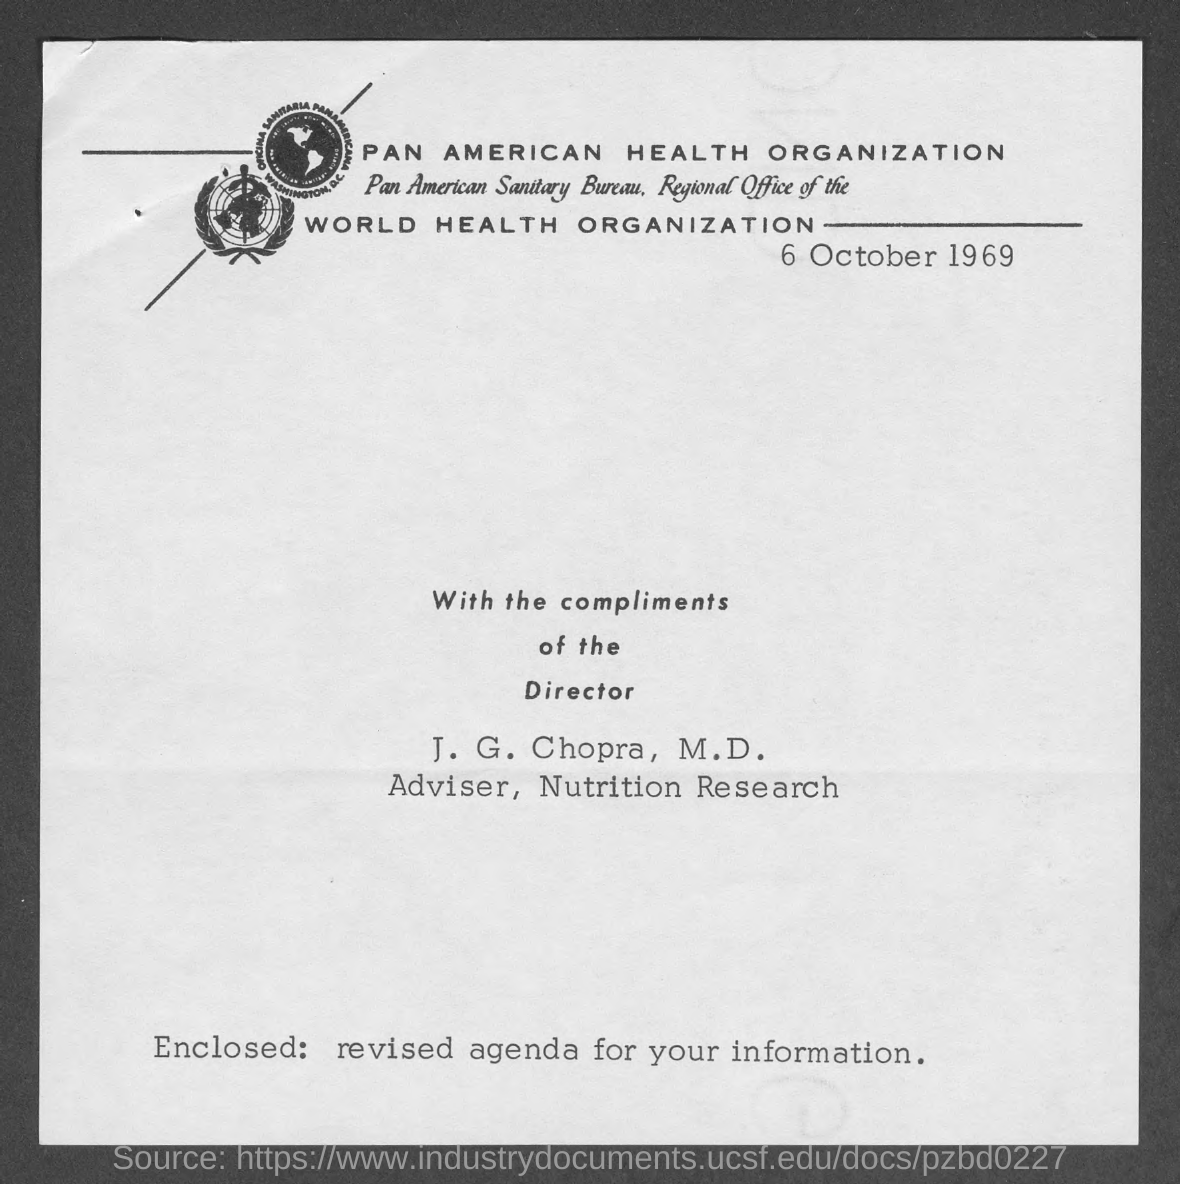Specify some key components in this picture. The date mentioned in this document is 6 October 1969. The identity of the individual who serves as the Adviser for Nutrition Research is J. G. Chopra, M.D. 